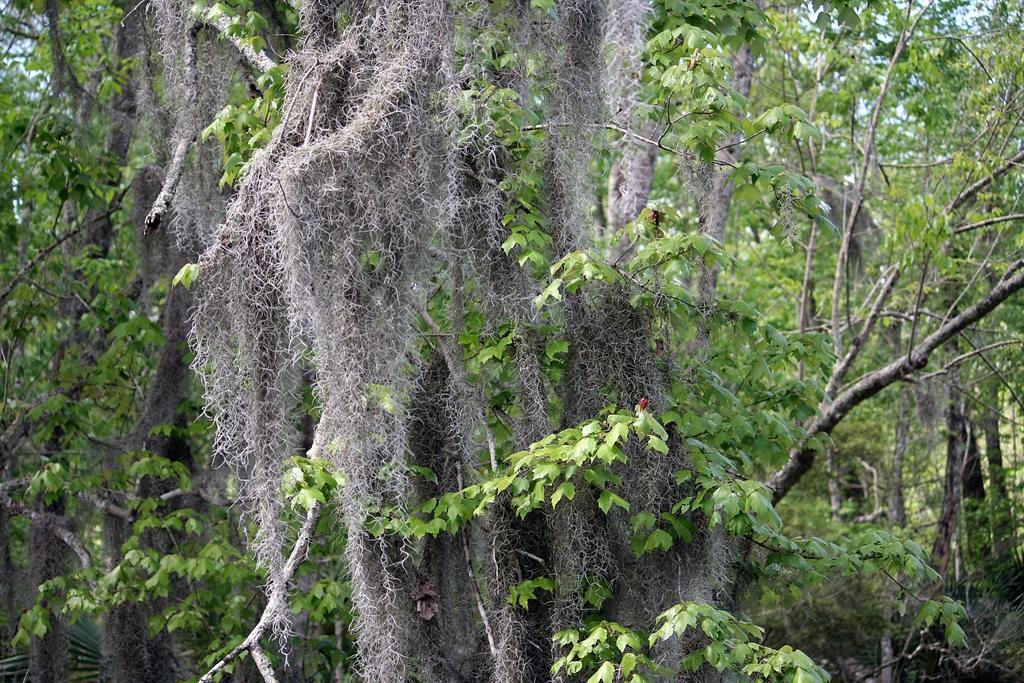Could you give a brief overview of what you see in this image? In this picture we can see trees are present. At the top of the image sky is there. 